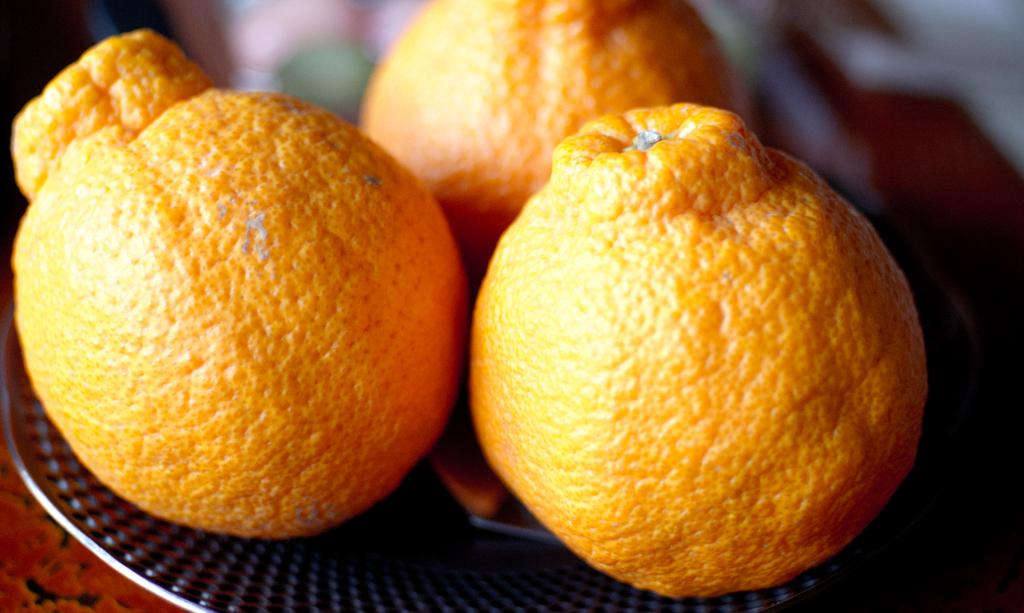What type of fruit is on the plate in the image? There are oranges on a plate in the image. What color is the hat worn by the orange in the image? There is no hat worn by the orange in the image, as oranges are fruit and do not wear hats. 